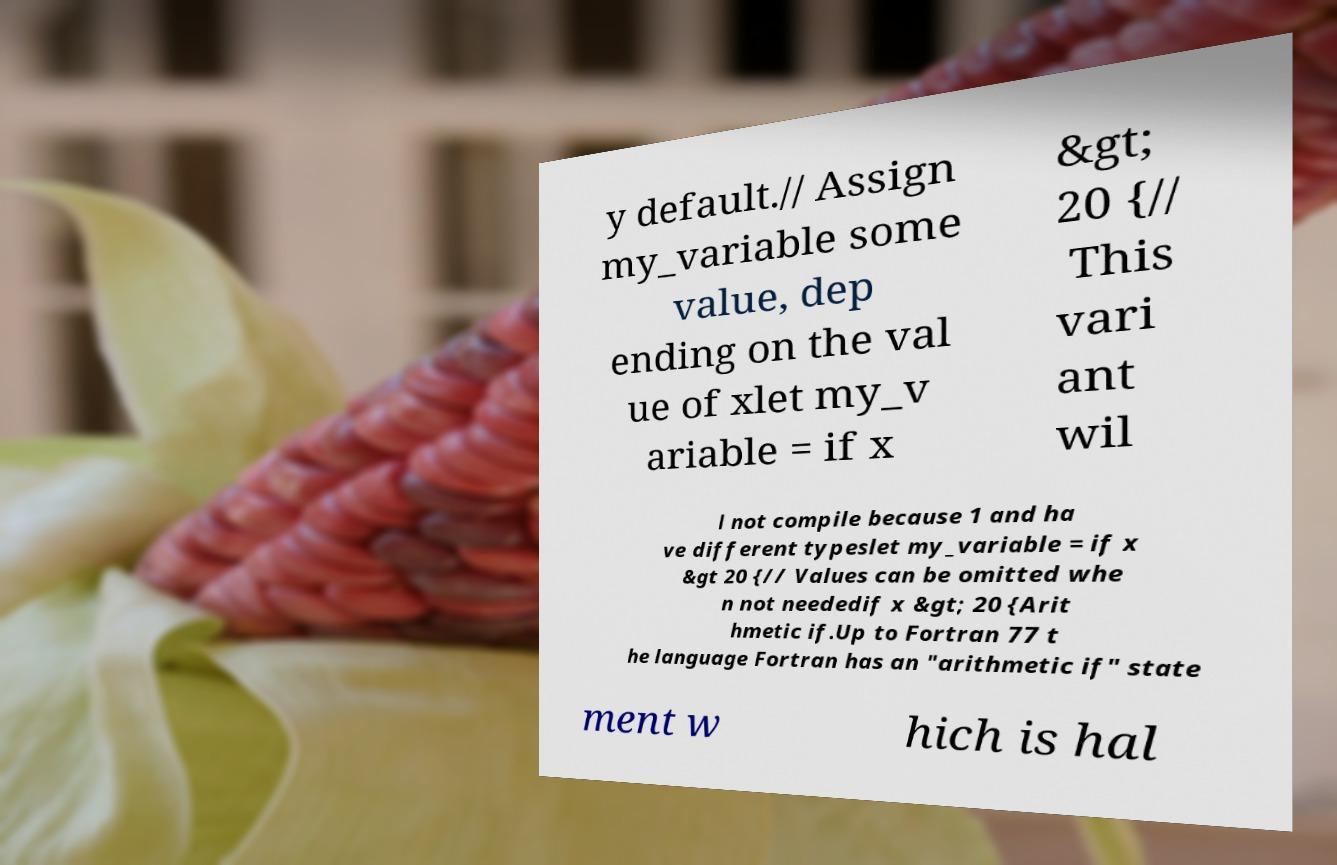Can you read and provide the text displayed in the image?This photo seems to have some interesting text. Can you extract and type it out for me? y default.// Assign my_variable some value, dep ending on the val ue of xlet my_v ariable = if x &gt; 20 {// This vari ant wil l not compile because 1 and ha ve different typeslet my_variable = if x &gt 20 {// Values can be omitted whe n not neededif x &gt; 20 {Arit hmetic if.Up to Fortran 77 t he language Fortran has an "arithmetic if" state ment w hich is hal 